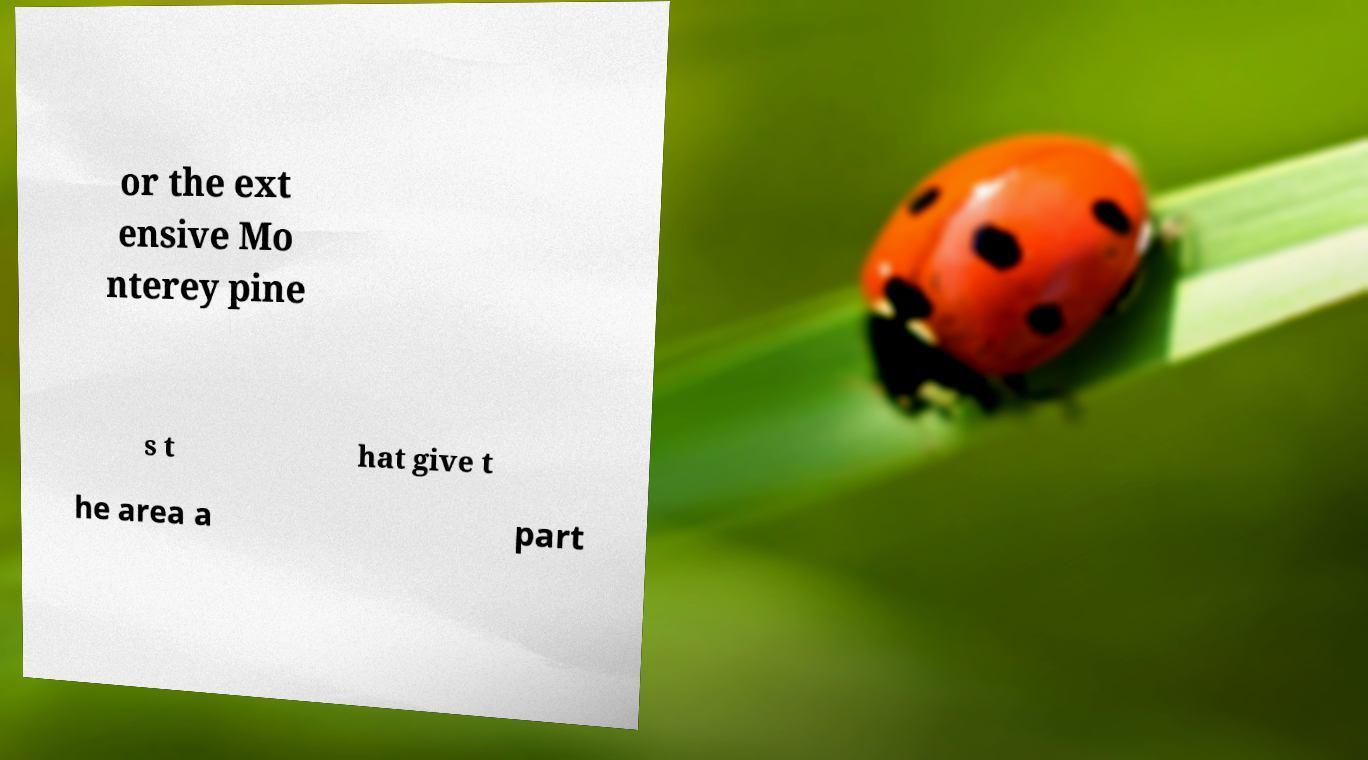Can you read and provide the text displayed in the image?This photo seems to have some interesting text. Can you extract and type it out for me? or the ext ensive Mo nterey pine s t hat give t he area a part 